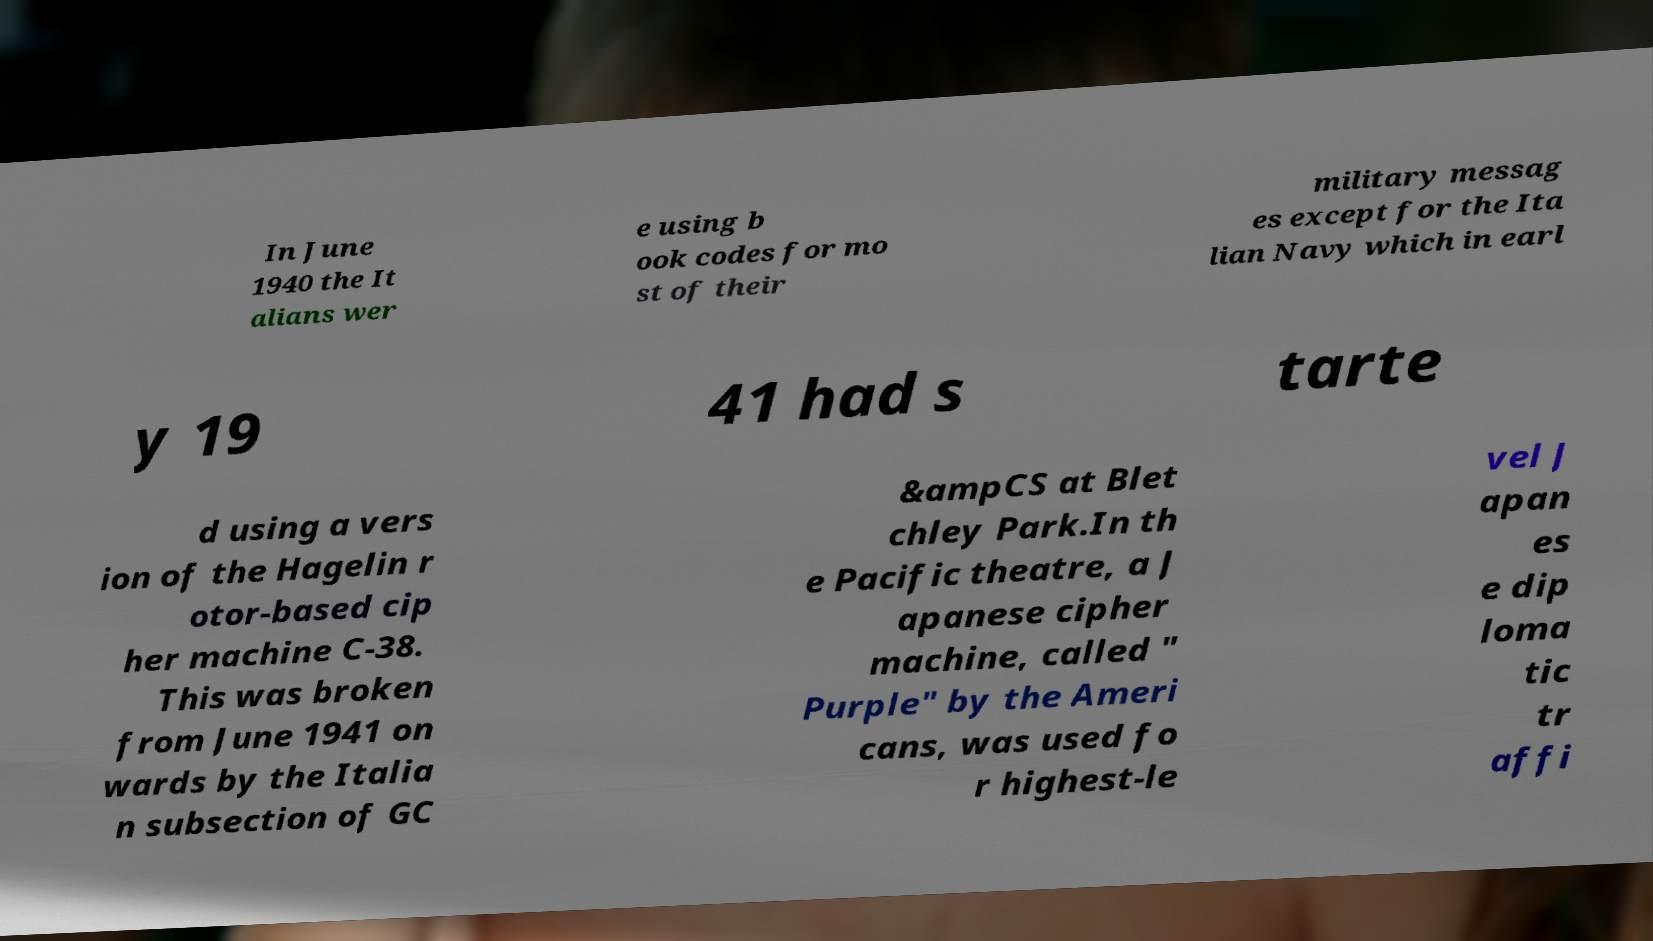Can you read and provide the text displayed in the image?This photo seems to have some interesting text. Can you extract and type it out for me? In June 1940 the It alians wer e using b ook codes for mo st of their military messag es except for the Ita lian Navy which in earl y 19 41 had s tarte d using a vers ion of the Hagelin r otor-based cip her machine C-38. This was broken from June 1941 on wards by the Italia n subsection of GC &ampCS at Blet chley Park.In th e Pacific theatre, a J apanese cipher machine, called " Purple" by the Ameri cans, was used fo r highest-le vel J apan es e dip loma tic tr affi 